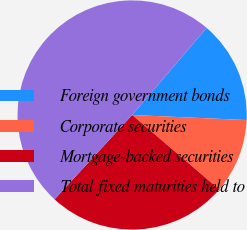<chart> <loc_0><loc_0><loc_500><loc_500><pie_chart><fcel>Foreign government bonds<fcel>Corporate securities<fcel>Mortgage-backed securities<fcel>Total fixed maturities held to<nl><fcel>14.44%<fcel>10.56%<fcel>25.57%<fcel>49.43%<nl></chart> 